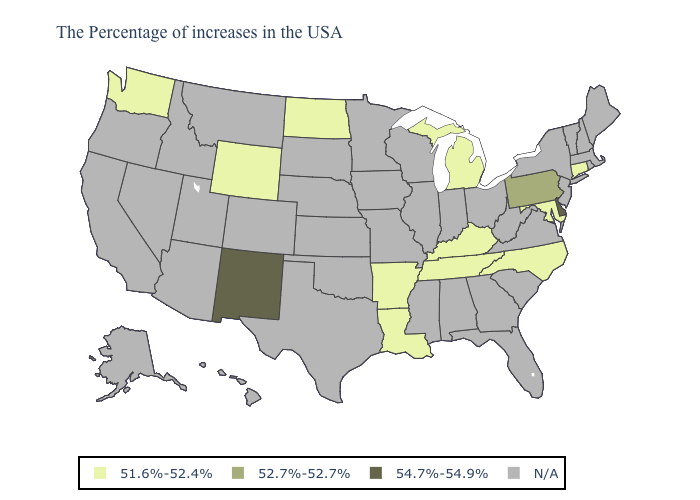Which states have the lowest value in the USA?
Short answer required. Connecticut, Maryland, North Carolina, Michigan, Kentucky, Tennessee, Louisiana, Arkansas, North Dakota, Wyoming, Washington. Which states have the lowest value in the USA?
Concise answer only. Connecticut, Maryland, North Carolina, Michigan, Kentucky, Tennessee, Louisiana, Arkansas, North Dakota, Wyoming, Washington. Name the states that have a value in the range N/A?
Be succinct. Maine, Massachusetts, Rhode Island, New Hampshire, Vermont, New York, New Jersey, Virginia, South Carolina, West Virginia, Ohio, Florida, Georgia, Indiana, Alabama, Wisconsin, Illinois, Mississippi, Missouri, Minnesota, Iowa, Kansas, Nebraska, Oklahoma, Texas, South Dakota, Colorado, Utah, Montana, Arizona, Idaho, Nevada, California, Oregon, Alaska, Hawaii. Is the legend a continuous bar?
Give a very brief answer. No. What is the highest value in the Northeast ?
Short answer required. 52.7%-52.7%. What is the highest value in the MidWest ?
Concise answer only. 51.6%-52.4%. What is the value of Hawaii?
Give a very brief answer. N/A. Among the states that border Delaware , which have the lowest value?
Concise answer only. Maryland. Name the states that have a value in the range 51.6%-52.4%?
Quick response, please. Connecticut, Maryland, North Carolina, Michigan, Kentucky, Tennessee, Louisiana, Arkansas, North Dakota, Wyoming, Washington. Does Delaware have the lowest value in the South?
Concise answer only. No. 